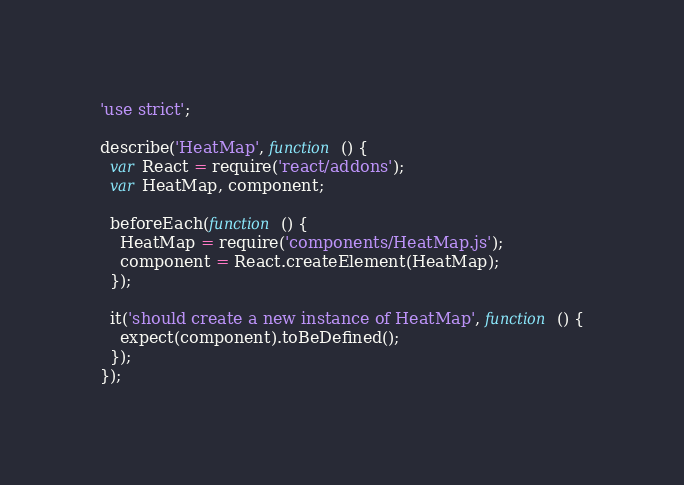Convert code to text. <code><loc_0><loc_0><loc_500><loc_500><_JavaScript_>'use strict';

describe('HeatMap', function () {
  var React = require('react/addons');
  var HeatMap, component;

  beforeEach(function () {
    HeatMap = require('components/HeatMap.js');
    component = React.createElement(HeatMap);
  });

  it('should create a new instance of HeatMap', function () {
    expect(component).toBeDefined();
  });
});
</code> 